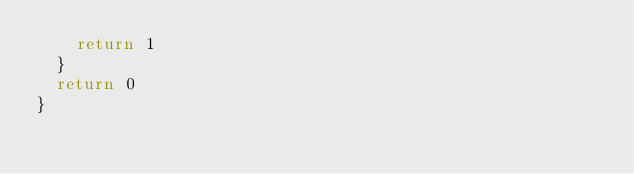<code> <loc_0><loc_0><loc_500><loc_500><_Go_>		return 1
	}
	return 0
}
</code> 